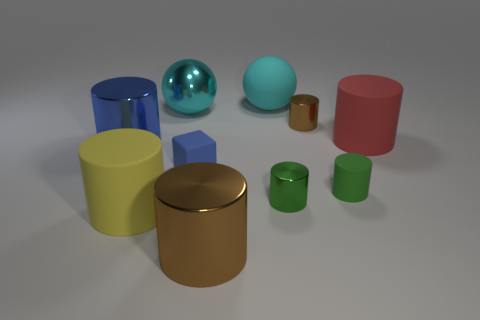Are there fewer brown shiny cylinders behind the tiny brown object than yellow things that are behind the yellow cylinder?
Provide a short and direct response. No. Is the rubber cube the same size as the green rubber thing?
Your answer should be compact. Yes. What shape is the matte object that is both right of the big yellow cylinder and left of the cyan matte sphere?
Keep it short and to the point. Cube. How many large yellow cylinders are made of the same material as the blue cylinder?
Your answer should be very brief. 0. There is a blue object in front of the blue metal thing; what number of tiny rubber things are right of it?
Provide a short and direct response. 1. There is a large matte thing behind the metallic sphere behind the rubber cylinder behind the tiny blue matte object; what is its shape?
Your response must be concise. Sphere. What is the size of the metallic object that is the same color as the matte sphere?
Provide a succinct answer. Large. What number of objects are either blue objects or big yellow cylinders?
Ensure brevity in your answer.  3. The rubber ball that is the same size as the cyan metal sphere is what color?
Your response must be concise. Cyan. There is a tiny brown metallic thing; is its shape the same as the tiny rubber thing left of the green rubber cylinder?
Ensure brevity in your answer.  No. 